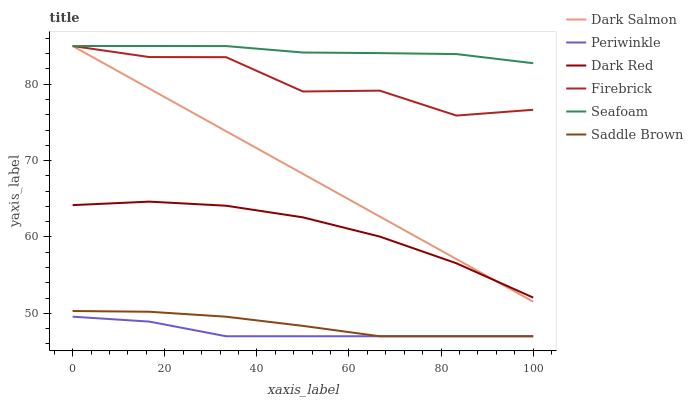Does Periwinkle have the minimum area under the curve?
Answer yes or no. Yes. Does Seafoam have the maximum area under the curve?
Answer yes or no. Yes. Does Firebrick have the minimum area under the curve?
Answer yes or no. No. Does Firebrick have the maximum area under the curve?
Answer yes or no. No. Is Dark Salmon the smoothest?
Answer yes or no. Yes. Is Firebrick the roughest?
Answer yes or no. Yes. Is Firebrick the smoothest?
Answer yes or no. No. Is Dark Salmon the roughest?
Answer yes or no. No. Does Periwinkle have the lowest value?
Answer yes or no. Yes. Does Firebrick have the lowest value?
Answer yes or no. No. Does Seafoam have the highest value?
Answer yes or no. Yes. Does Periwinkle have the highest value?
Answer yes or no. No. Is Saddle Brown less than Seafoam?
Answer yes or no. Yes. Is Dark Red greater than Periwinkle?
Answer yes or no. Yes. Does Firebrick intersect Seafoam?
Answer yes or no. Yes. Is Firebrick less than Seafoam?
Answer yes or no. No. Is Firebrick greater than Seafoam?
Answer yes or no. No. Does Saddle Brown intersect Seafoam?
Answer yes or no. No. 